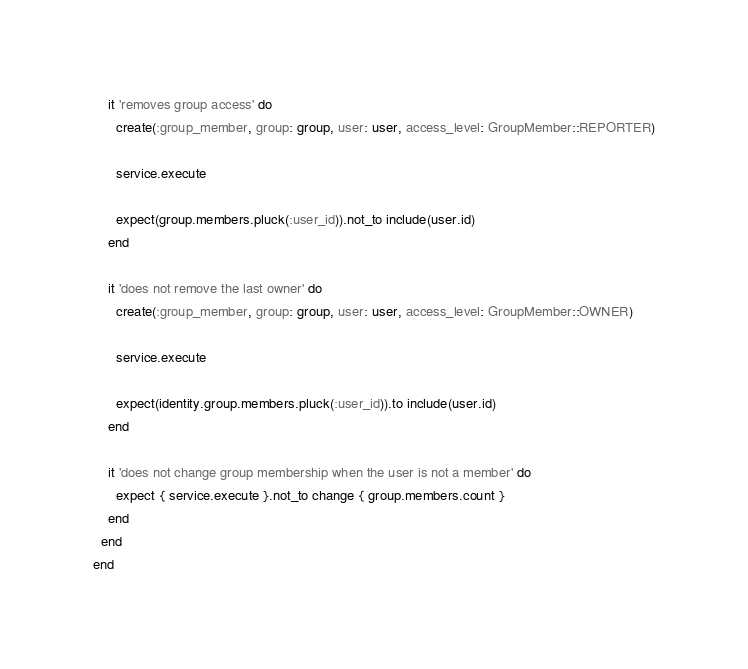Convert code to text. <code><loc_0><loc_0><loc_500><loc_500><_Ruby_>
    it 'removes group access' do
      create(:group_member, group: group, user: user, access_level: GroupMember::REPORTER)

      service.execute

      expect(group.members.pluck(:user_id)).not_to include(user.id)
    end

    it 'does not remove the last owner' do
      create(:group_member, group: group, user: user, access_level: GroupMember::OWNER)

      service.execute

      expect(identity.group.members.pluck(:user_id)).to include(user.id)
    end

    it 'does not change group membership when the user is not a member' do
      expect { service.execute }.not_to change { group.members.count }
    end
  end
end
</code> 